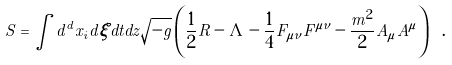Convert formula to latex. <formula><loc_0><loc_0><loc_500><loc_500>S = \int d ^ { d } x _ { i } d \xi d t d z \sqrt { - g } \left ( \frac { 1 } { 2 } R - \Lambda - \frac { 1 } { 4 } F _ { \mu \nu } F ^ { \mu \nu } - \frac { m ^ { 2 } } { 2 } A _ { \mu } A ^ { \mu } \right ) \ .</formula> 